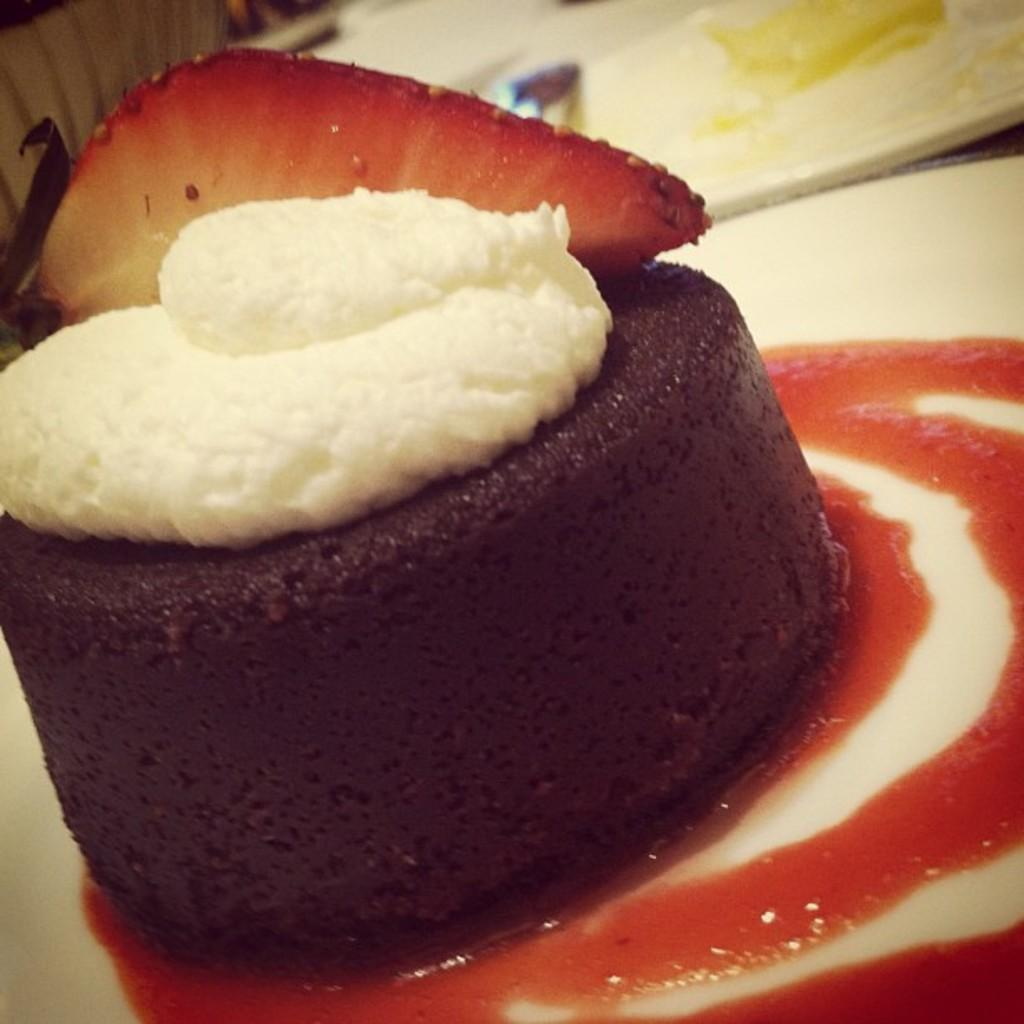What is on the plate in the image? There is a food item on the plate in the image. How many ghosts are present in the image? There are no ghosts present in the image; it features a plate with a food item. What rule is being enforced in the image? There is no rule being enforced in the image; it simply shows a plate with a food item. 